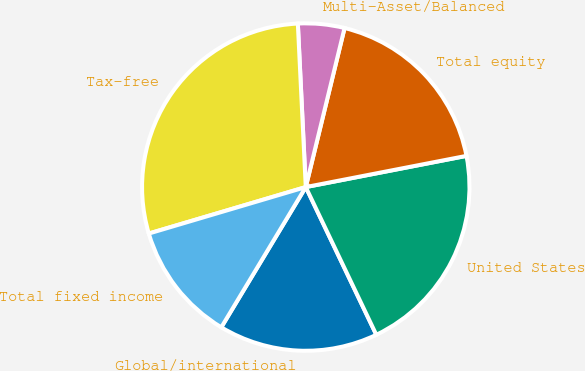Convert chart to OTSL. <chart><loc_0><loc_0><loc_500><loc_500><pie_chart><fcel>Global/international<fcel>United States<fcel>Total equity<fcel>Multi-Asset/Balanced<fcel>Tax-free<fcel>Total fixed income<nl><fcel>15.72%<fcel>20.96%<fcel>18.14%<fcel>4.58%<fcel>28.81%<fcel>11.79%<nl></chart> 